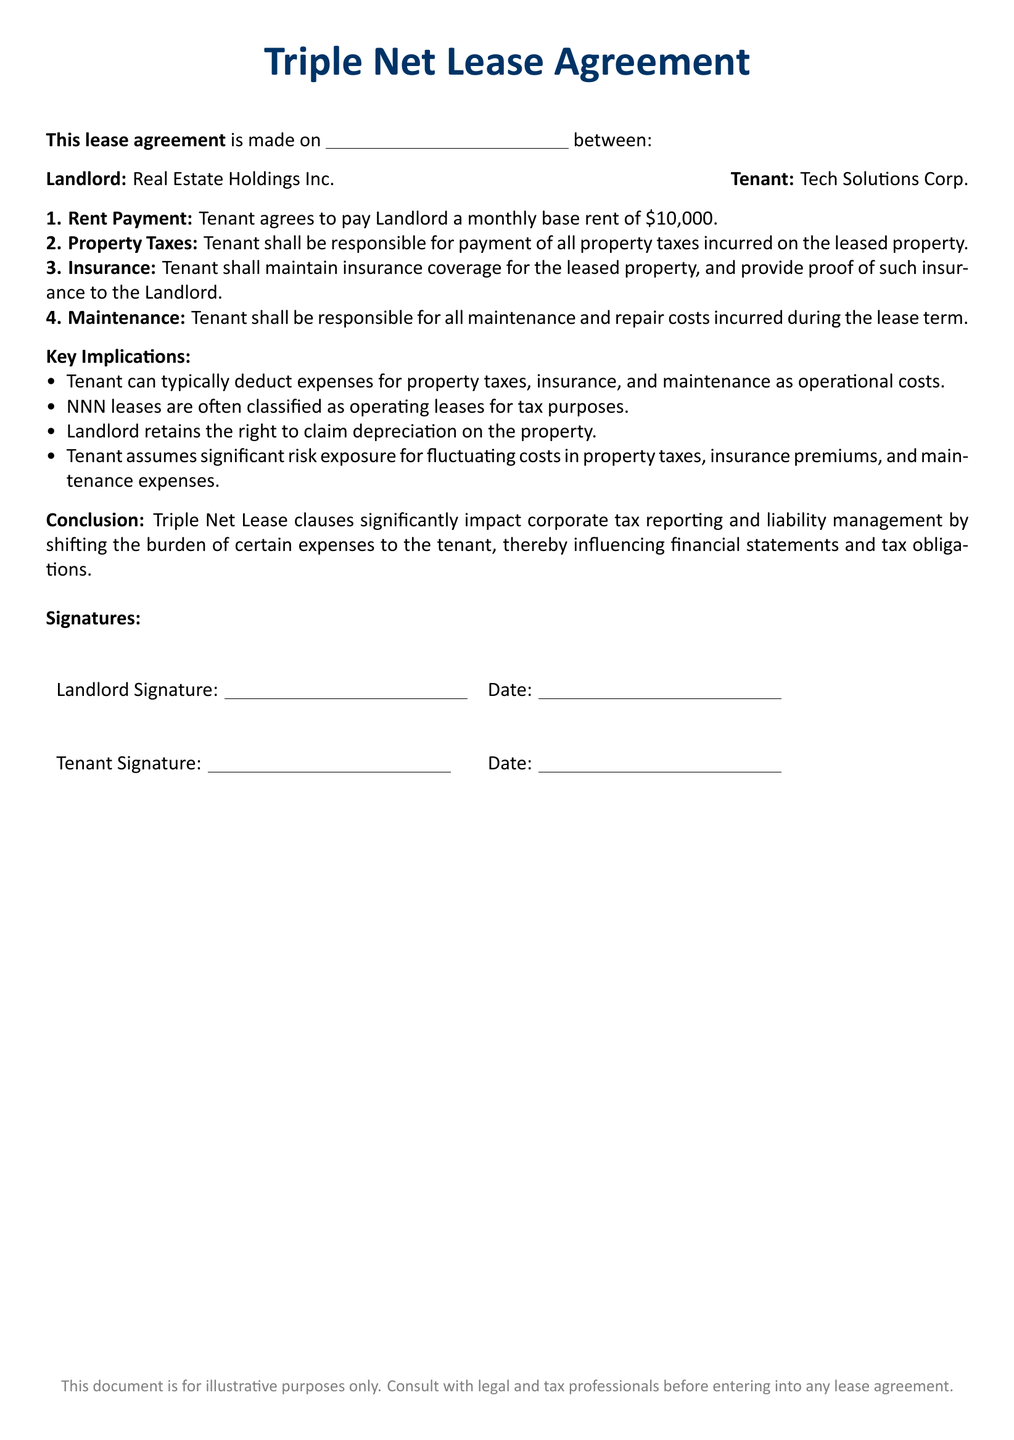What is the monthly base rent? The monthly base rent is specified in the lease agreement as \$10,000.
Answer: \$10,000 Who is responsible for property taxes? The lease states that the Tenant is responsible for payment of all property taxes incurred on the leased property.
Answer: Tenant What must the Tenant maintain? The Tenant must maintain insurance coverage for the leased property as per the lease agreement.
Answer: Insurance coverage What are the Tenant's financial responsibilities? The lease specifies Tenant is responsible for property taxes, insurance, and maintenance costs incurred during the lease term.
Answer: Property taxes, insurance, and maintenance What rights does the Landlord retain? The Landlord retains the right to claim depreciation on the property, which is noted in the key implications.
Answer: Claim depreciation How do NNN leases classify for tax purposes? The document indicates that NNN leases are often classified as operating leases for tax purposes.
Answer: Operating leases Who signs the lease agreement? The lease agreement must be signed by both the Landlord and Tenant as indicated at the end of the document.
Answer: Landlord and Tenant What is the primary implication of Triple Net Lease Clauses? The conclusion states that Triple Net Lease clauses significantly impact corporate tax reporting and liability management.
Answer: Impact on corporate tax reporting What is the purpose of this document? The footnote indicates this document is for illustrative purposes and advises consultation with legal and tax professionals.
Answer: Illustrative purposes 